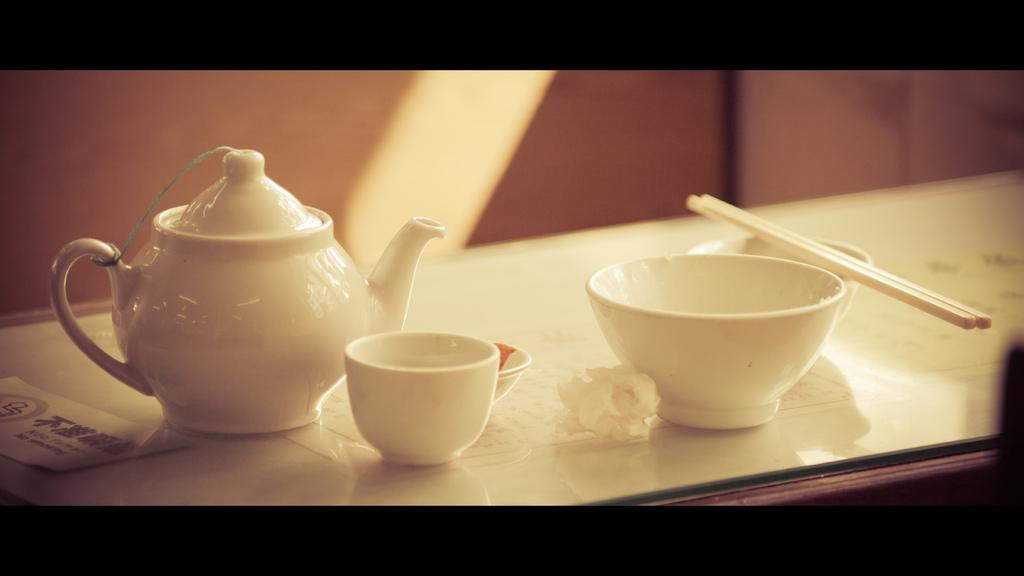What is the main object in the image? There is a kettle in the image. How many cups are visible in the image? There are two cups in the image. What is placed on one of the cups? Chopsticks are placed on one of the cups. What is the surface on which the cups and chopsticks are placed? The cups and chopsticks are placed on a glass. What type of insect can be seen crawling on the kettle in the image? There is no insect present on the kettle or any other part of the image. 